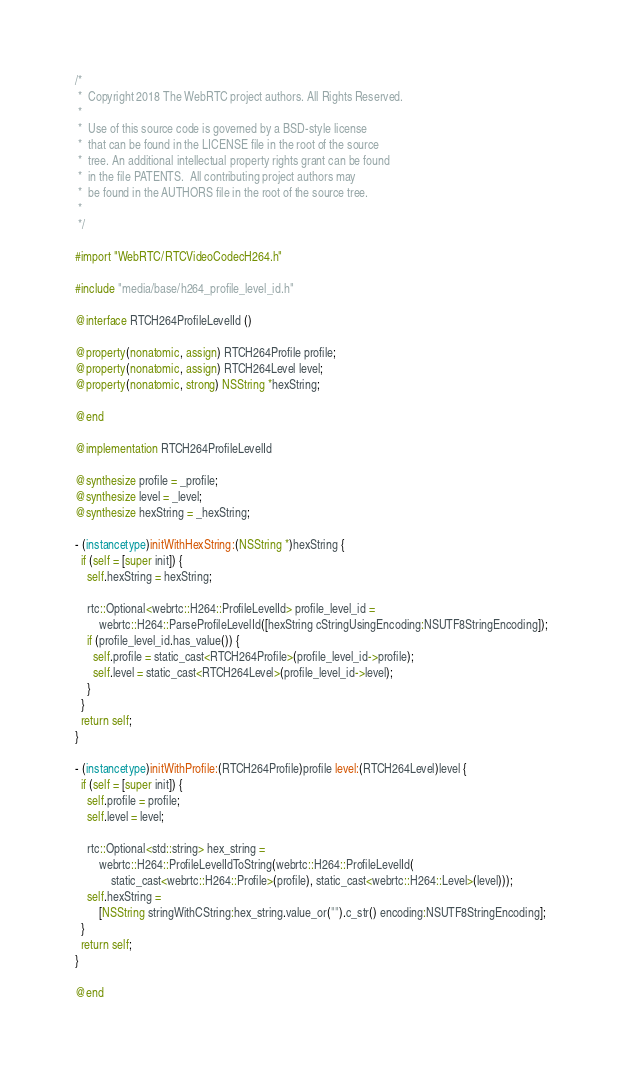Convert code to text. <code><loc_0><loc_0><loc_500><loc_500><_ObjectiveC_>/*
 *  Copyright 2018 The WebRTC project authors. All Rights Reserved.
 *
 *  Use of this source code is governed by a BSD-style license
 *  that can be found in the LICENSE file in the root of the source
 *  tree. An additional intellectual property rights grant can be found
 *  in the file PATENTS.  All contributing project authors may
 *  be found in the AUTHORS file in the root of the source tree.
 *
 */

#import "WebRTC/RTCVideoCodecH264.h"

#include "media/base/h264_profile_level_id.h"

@interface RTCH264ProfileLevelId ()

@property(nonatomic, assign) RTCH264Profile profile;
@property(nonatomic, assign) RTCH264Level level;
@property(nonatomic, strong) NSString *hexString;

@end

@implementation RTCH264ProfileLevelId

@synthesize profile = _profile;
@synthesize level = _level;
@synthesize hexString = _hexString;

- (instancetype)initWithHexString:(NSString *)hexString {
  if (self = [super init]) {
    self.hexString = hexString;

    rtc::Optional<webrtc::H264::ProfileLevelId> profile_level_id =
        webrtc::H264::ParseProfileLevelId([hexString cStringUsingEncoding:NSUTF8StringEncoding]);
    if (profile_level_id.has_value()) {
      self.profile = static_cast<RTCH264Profile>(profile_level_id->profile);
      self.level = static_cast<RTCH264Level>(profile_level_id->level);
    }
  }
  return self;
}

- (instancetype)initWithProfile:(RTCH264Profile)profile level:(RTCH264Level)level {
  if (self = [super init]) {
    self.profile = profile;
    self.level = level;

    rtc::Optional<std::string> hex_string =
        webrtc::H264::ProfileLevelIdToString(webrtc::H264::ProfileLevelId(
            static_cast<webrtc::H264::Profile>(profile), static_cast<webrtc::H264::Level>(level)));
    self.hexString =
        [NSString stringWithCString:hex_string.value_or("").c_str() encoding:NSUTF8StringEncoding];
  }
  return self;
}

@end
</code> 